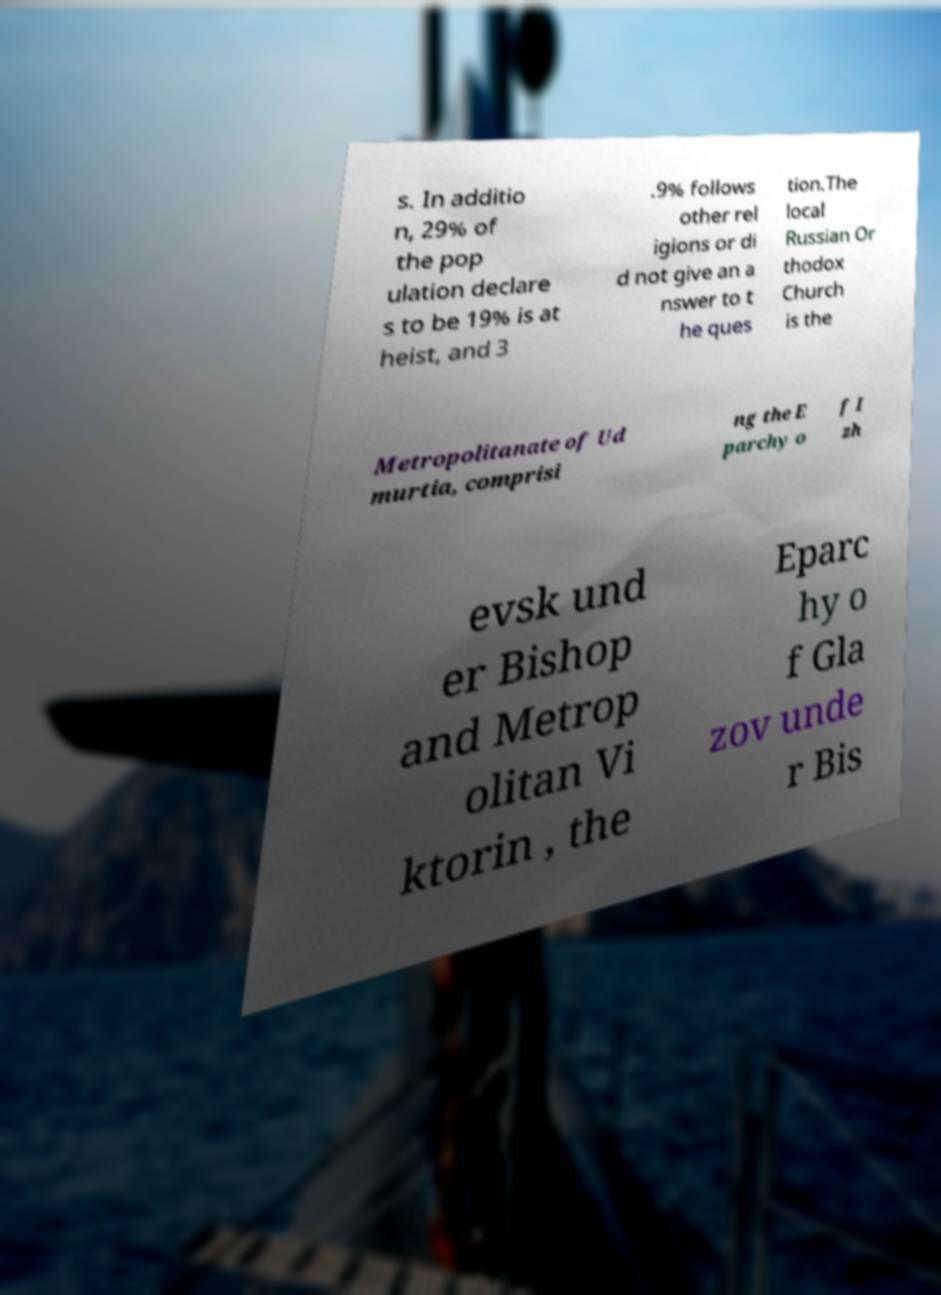Please identify and transcribe the text found in this image. s. In additio n, 29% of the pop ulation declare s to be 19% is at heist, and 3 .9% follows other rel igions or di d not give an a nswer to t he ques tion.The local Russian Or thodox Church is the Metropolitanate of Ud murtia, comprisi ng the E parchy o f I zh evsk und er Bishop and Metrop olitan Vi ktorin , the Eparc hy o f Gla zov unde r Bis 